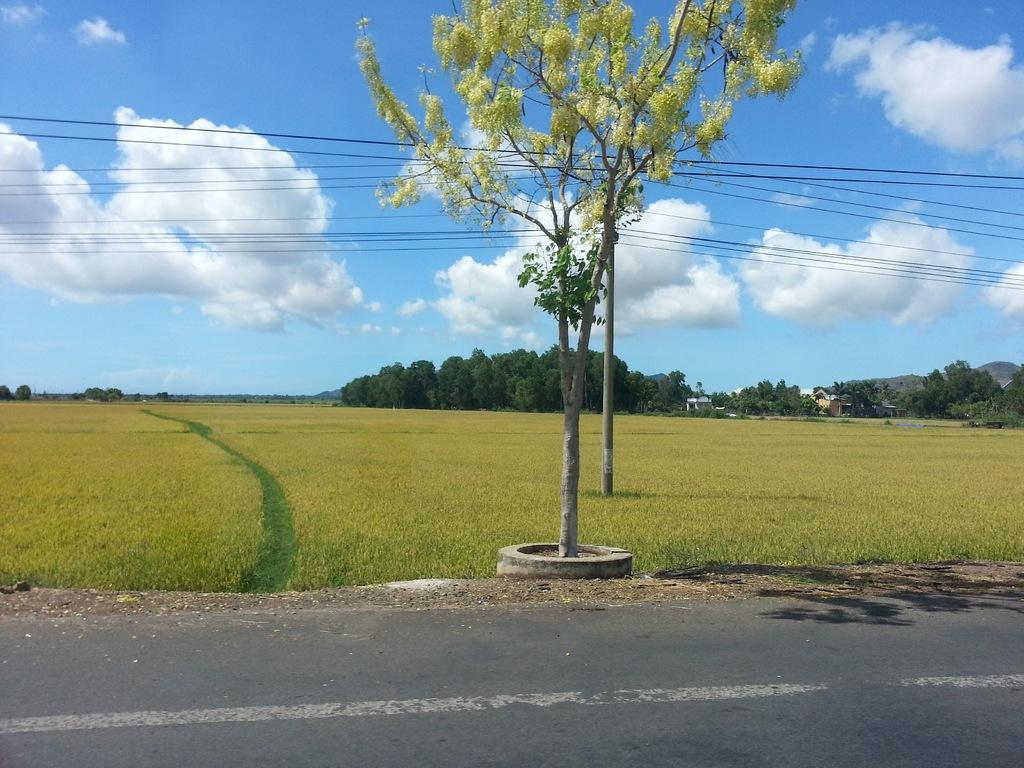Can you describe this image briefly? In the image there is road in the front, behind it there is grass land with trees in the background and above its sky with clouds. 